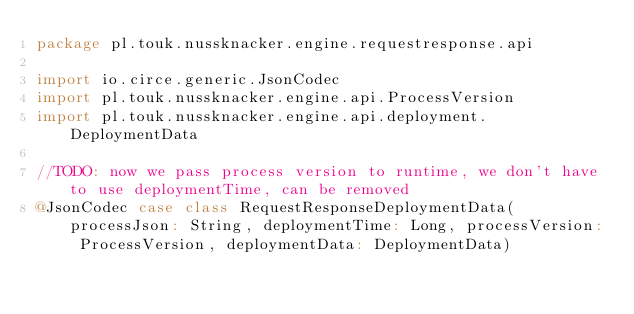Convert code to text. <code><loc_0><loc_0><loc_500><loc_500><_Scala_>package pl.touk.nussknacker.engine.requestresponse.api

import io.circe.generic.JsonCodec
import pl.touk.nussknacker.engine.api.ProcessVersion
import pl.touk.nussknacker.engine.api.deployment.DeploymentData

//TODO: now we pass process version to runtime, we don't have to use deploymentTime, can be removed
@JsonCodec case class RequestResponseDeploymentData(processJson: String, deploymentTime: Long, processVersion: ProcessVersion, deploymentData: DeploymentData)</code> 